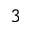Convert formula to latex. <formula><loc_0><loc_0><loc_500><loc_500>_ { 3 }</formula> 